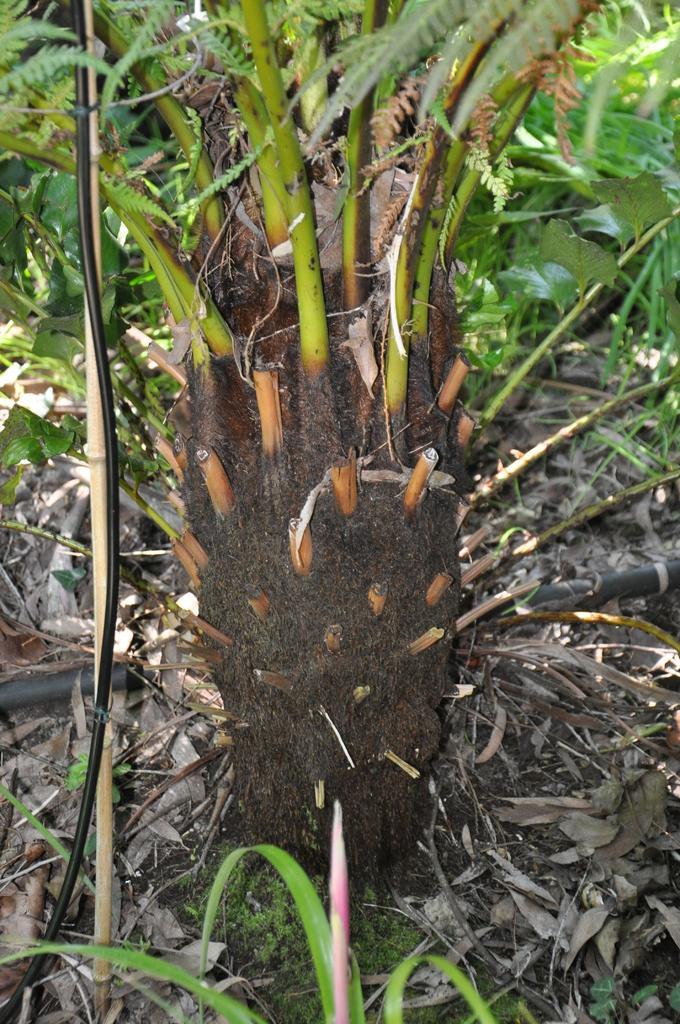How would you summarize this image in a sentence or two? This image consists of a plant. At the bottom, there is ground. And there are dry leaves on the ground. 